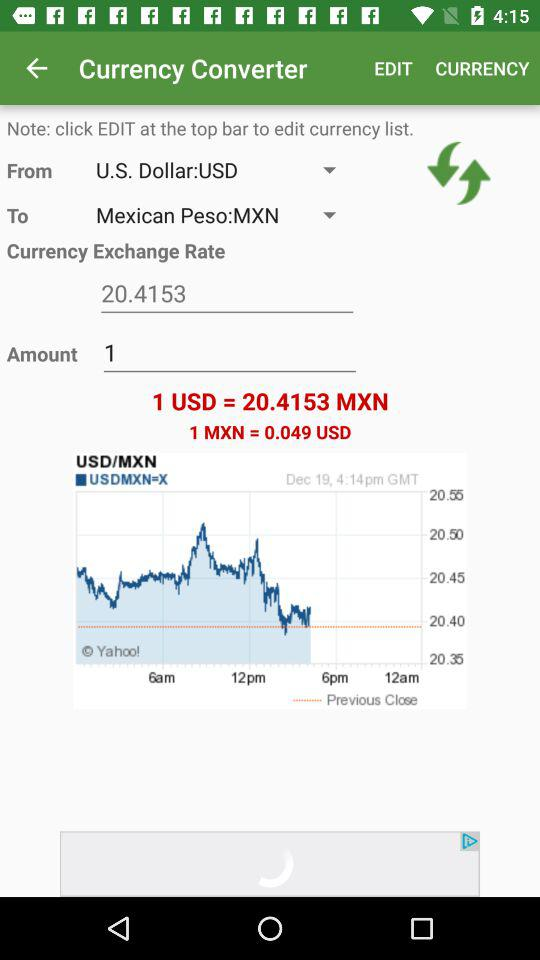What is the current currency exchange rate? The current currency exchange rate is 20.4153. 